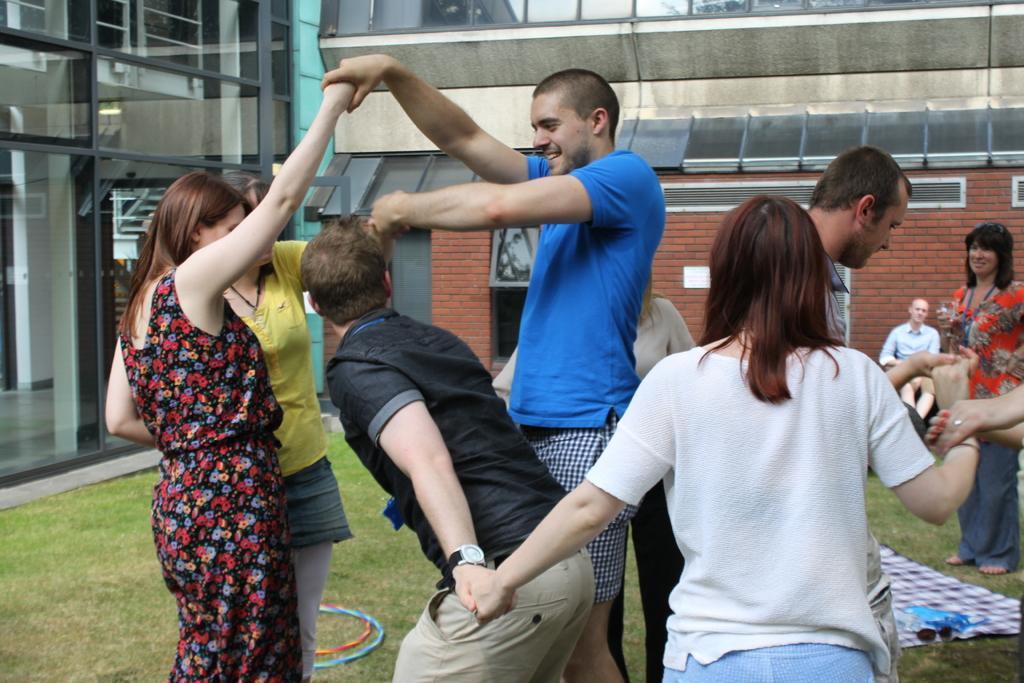Could you give a brief overview of what you see in this image? In the picture there are a group of people standing on the grass in front of a building, all of them are holding each others hands. 